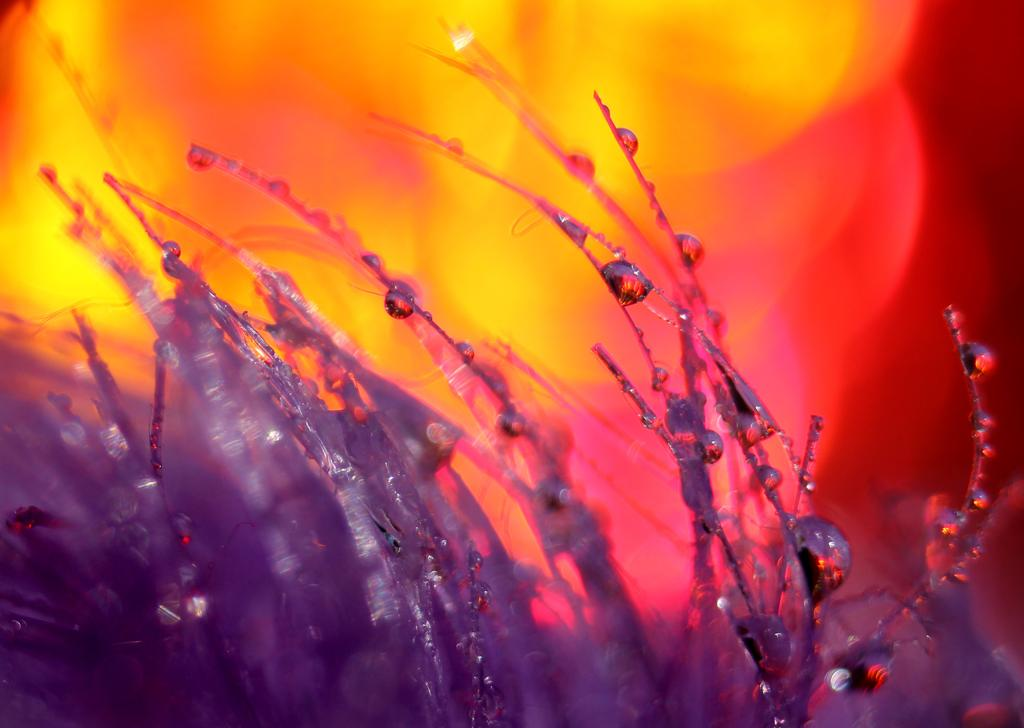What is the color of the objects in the image? The objects in the image are silver-colored. What can be seen in the background of the image? The background of the image is colorful. Are there any carriages visible in the image? There are no carriages present in the image. How many spiders can be seen in the image? There are no spiders present in the image. 